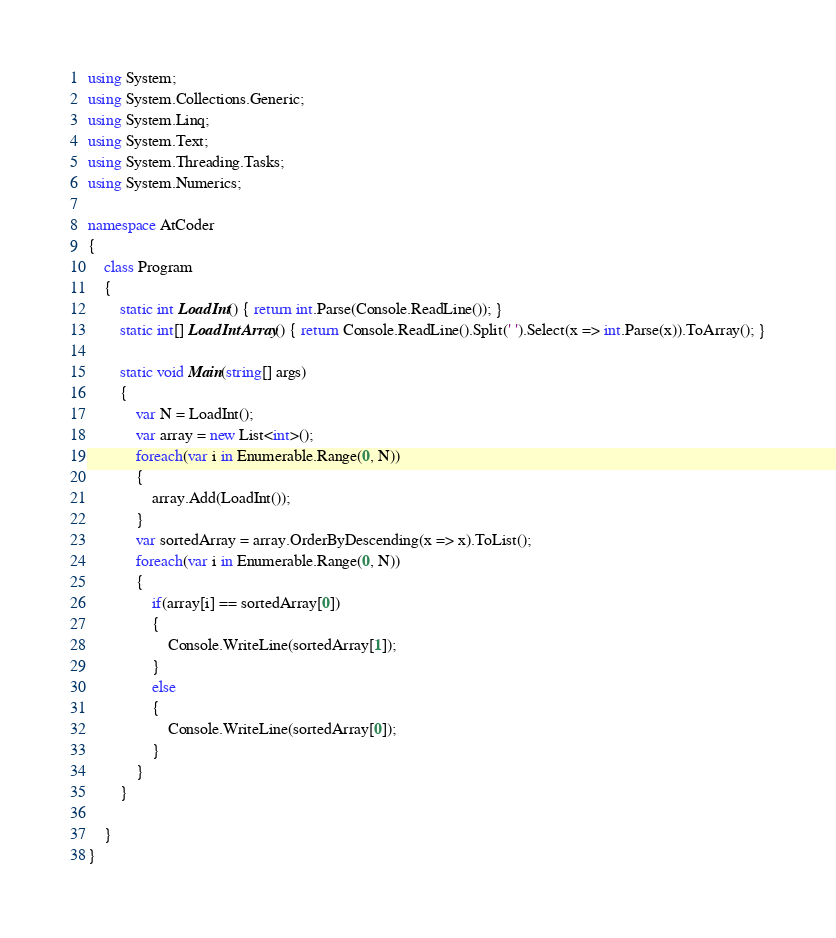Convert code to text. <code><loc_0><loc_0><loc_500><loc_500><_C#_>using System;
using System.Collections.Generic;
using System.Linq;
using System.Text;
using System.Threading.Tasks;
using System.Numerics;

namespace AtCoder
{
    class Program
    {
        static int LoadInt() { return int.Parse(Console.ReadLine()); }
        static int[] LoadIntArray() { return Console.ReadLine().Split(' ').Select(x => int.Parse(x)).ToArray(); }

        static void Main(string[] args)
        {
            var N = LoadInt();
            var array = new List<int>();
            foreach(var i in Enumerable.Range(0, N))
            {
                array.Add(LoadInt());
            }
            var sortedArray = array.OrderByDescending(x => x).ToList();
            foreach(var i in Enumerable.Range(0, N))
            {
                if(array[i] == sortedArray[0])
                {
                    Console.WriteLine(sortedArray[1]);
                }
                else
                {
                    Console.WriteLine(sortedArray[0]);
                }
            }
        }

    }
}
</code> 